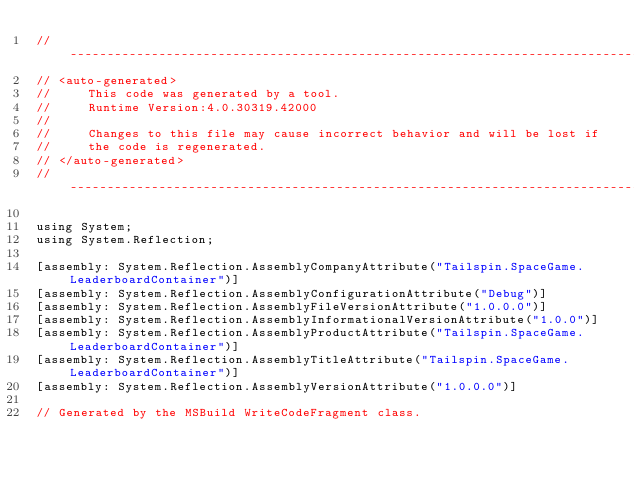<code> <loc_0><loc_0><loc_500><loc_500><_C#_>//------------------------------------------------------------------------------
// <auto-generated>
//     This code was generated by a tool.
//     Runtime Version:4.0.30319.42000
//
//     Changes to this file may cause incorrect behavior and will be lost if
//     the code is regenerated.
// </auto-generated>
//------------------------------------------------------------------------------

using System;
using System.Reflection;

[assembly: System.Reflection.AssemblyCompanyAttribute("Tailspin.SpaceGame.LeaderboardContainer")]
[assembly: System.Reflection.AssemblyConfigurationAttribute("Debug")]
[assembly: System.Reflection.AssemblyFileVersionAttribute("1.0.0.0")]
[assembly: System.Reflection.AssemblyInformationalVersionAttribute("1.0.0")]
[assembly: System.Reflection.AssemblyProductAttribute("Tailspin.SpaceGame.LeaderboardContainer")]
[assembly: System.Reflection.AssemblyTitleAttribute("Tailspin.SpaceGame.LeaderboardContainer")]
[assembly: System.Reflection.AssemblyVersionAttribute("1.0.0.0")]

// Generated by the MSBuild WriteCodeFragment class.

</code> 